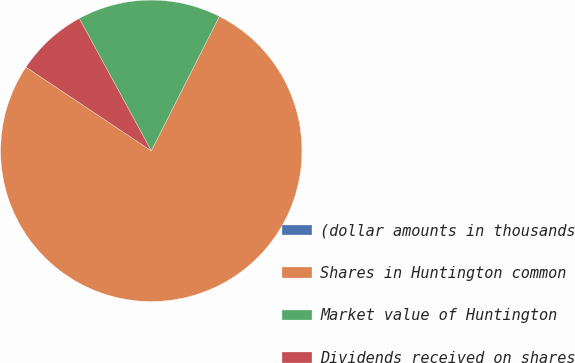Convert chart to OTSL. <chart><loc_0><loc_0><loc_500><loc_500><pie_chart><fcel>(dollar amounts in thousands<fcel>Shares in Huntington common<fcel>Market value of Huntington<fcel>Dividends received on shares<nl><fcel>0.01%<fcel>76.9%<fcel>15.39%<fcel>7.7%<nl></chart> 